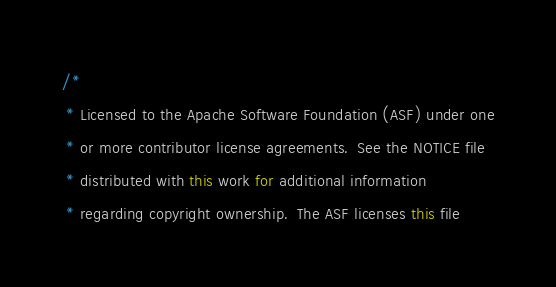<code> <loc_0><loc_0><loc_500><loc_500><_Java_>/*
 * Licensed to the Apache Software Foundation (ASF) under one
 * or more contributor license agreements.  See the NOTICE file
 * distributed with this work for additional information
 * regarding copyright ownership.  The ASF licenses this file</code> 